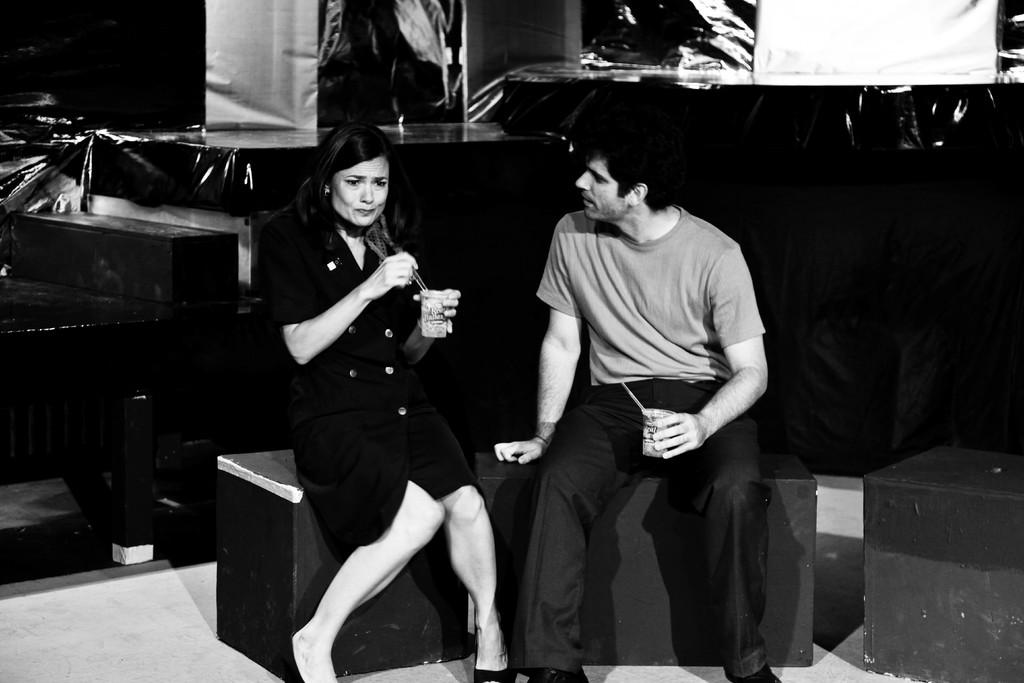Who is present in the image? There is a man and a woman in the image. What are the man and woman doing in the image? The man and woman are sitting. What are they holding in their hands? They are holding glasses in their hands. What can be observed about the background of the image? The background of the image is dark. What type of plastic object can be seen on the table in the image? There is no plastic object present on the table in the image. What book is the woman reading in the image? There is no book present in the image; the woman is holding a glass. 